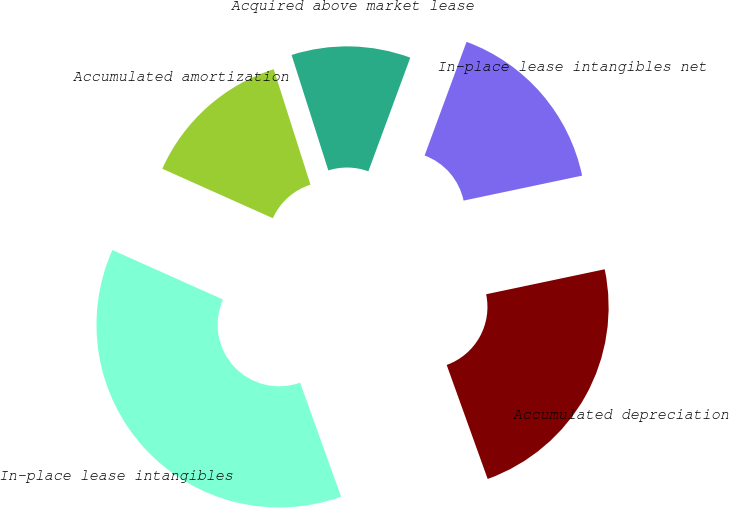<chart> <loc_0><loc_0><loc_500><loc_500><pie_chart><fcel>In-place lease intangibles<fcel>Accumulated depreciation<fcel>In-place lease intangibles net<fcel>Acquired above market lease<fcel>Accumulated amortization<nl><fcel>37.19%<fcel>22.81%<fcel>16.07%<fcel>10.53%<fcel>13.4%<nl></chart> 